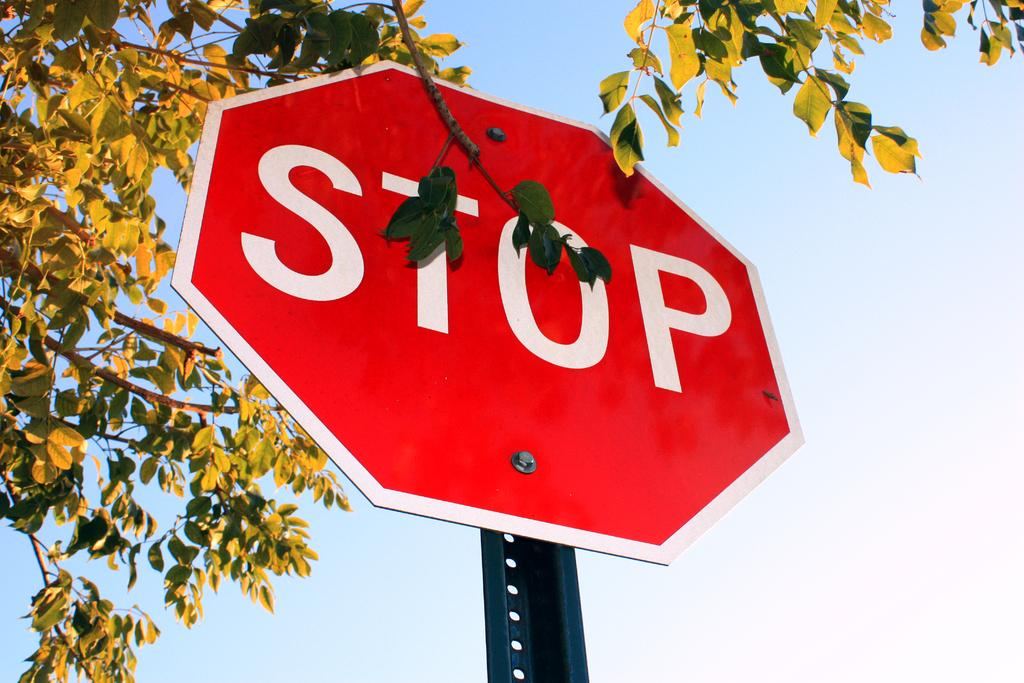<image>
Create a compact narrative representing the image presented. A stop sign in front of some leaves and a blue sky. 